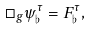Convert formula to latex. <formula><loc_0><loc_0><loc_500><loc_500>\Box _ { g } \psi ^ { \tau } _ { \flat } = F ^ { \tau } _ { \flat } ,</formula> 